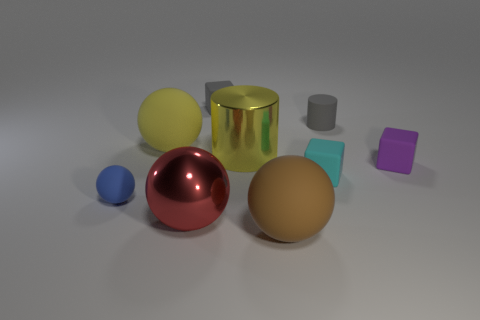How many things are yellow objects or gray rubber blocks?
Provide a succinct answer. 3. There is a tiny thing that is both right of the tiny ball and on the left side of the brown rubber thing; what is its shape?
Keep it short and to the point. Cube. Does the tiny block in front of the tiny purple cube have the same material as the small cylinder?
Your response must be concise. Yes. How many objects are big yellow balls or gray things on the right side of the big yellow cylinder?
Your answer should be very brief. 2. There is a cylinder that is the same material as the small purple object; what color is it?
Offer a terse response. Gray. How many small cyan blocks are made of the same material as the brown sphere?
Provide a succinct answer. 1. What number of cyan cylinders are there?
Keep it short and to the point. 0. There is a big metallic object that is behind the tiny cyan matte block; is its color the same as the big matte sphere to the right of the gray matte block?
Your answer should be compact. No. What number of brown rubber spheres are to the right of the cyan block?
Offer a very short reply. 0. There is a tiny thing that is the same color as the rubber cylinder; what is it made of?
Your answer should be compact. Rubber. 